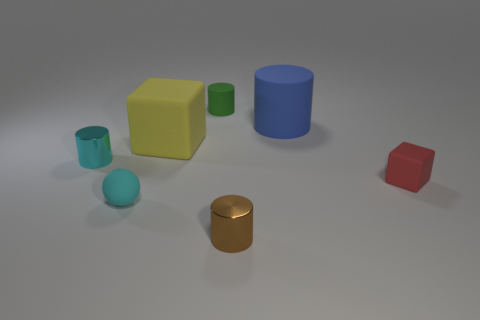Subtract all red cylinders. Subtract all red cubes. How many cylinders are left? 4 Add 1 tiny brown metallic cylinders. How many objects exist? 8 Subtract all balls. How many objects are left? 6 Add 6 big blue cylinders. How many big blue cylinders are left? 7 Add 5 small purple objects. How many small purple objects exist? 5 Subtract 0 cyan blocks. How many objects are left? 7 Subtract all tiny gray cylinders. Subtract all red rubber cubes. How many objects are left? 6 